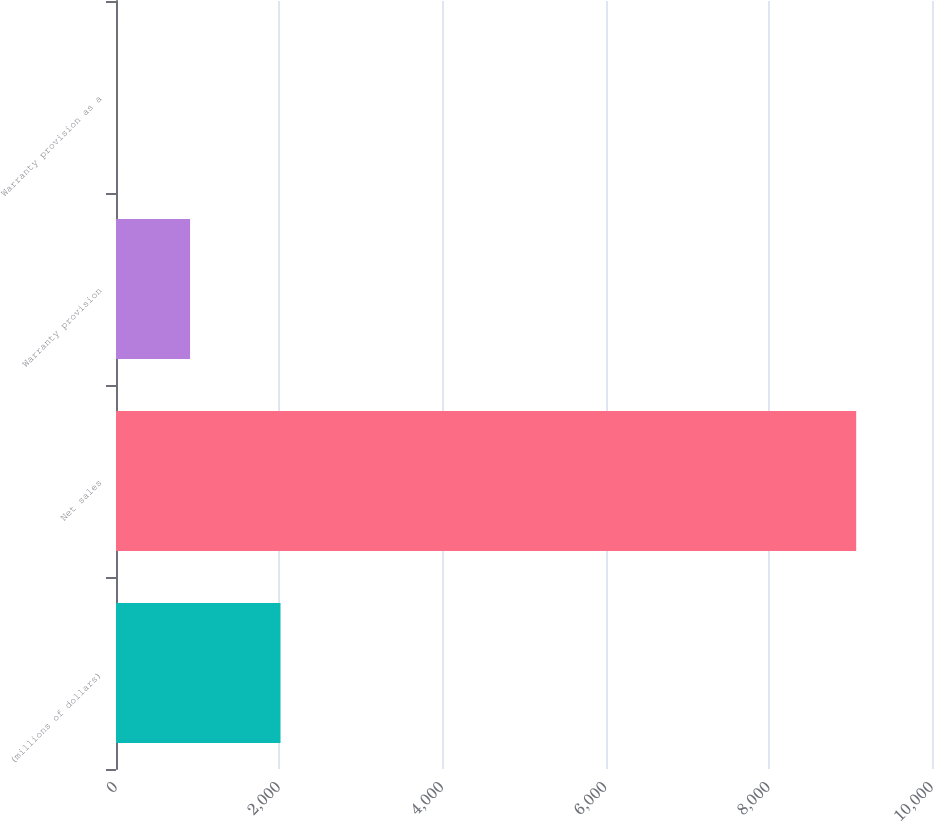Convert chart to OTSL. <chart><loc_0><loc_0><loc_500><loc_500><bar_chart><fcel>(millions of dollars)<fcel>Net sales<fcel>Warranty provision<fcel>Warranty provision as a<nl><fcel>2016<fcel>9071<fcel>907.73<fcel>0.7<nl></chart> 